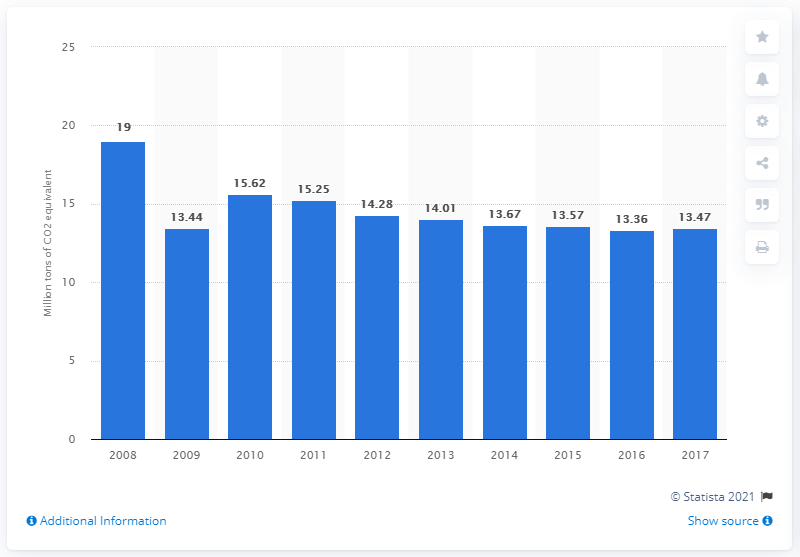How much CO2 equivalent did Belgium emit from fuel combustion in 2017?
 13.47 